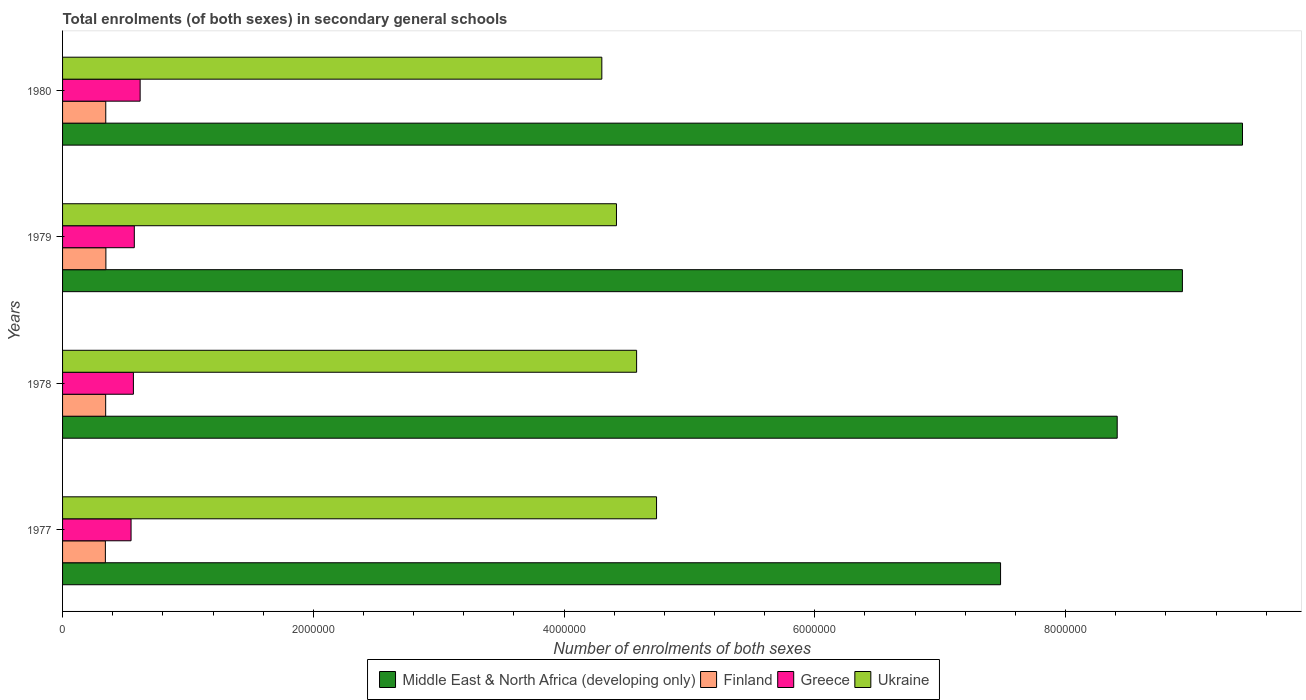How many different coloured bars are there?
Provide a succinct answer. 4. Are the number of bars per tick equal to the number of legend labels?
Offer a very short reply. Yes. Are the number of bars on each tick of the Y-axis equal?
Your answer should be very brief. Yes. How many bars are there on the 1st tick from the top?
Offer a terse response. 4. What is the label of the 2nd group of bars from the top?
Your answer should be compact. 1979. In how many cases, is the number of bars for a given year not equal to the number of legend labels?
Provide a succinct answer. 0. What is the number of enrolments in secondary schools in Ukraine in 1979?
Provide a succinct answer. 4.42e+06. Across all years, what is the maximum number of enrolments in secondary schools in Greece?
Keep it short and to the point. 6.19e+05. Across all years, what is the minimum number of enrolments in secondary schools in Ukraine?
Ensure brevity in your answer.  4.30e+06. What is the total number of enrolments in secondary schools in Ukraine in the graph?
Provide a short and direct response. 1.80e+07. What is the difference between the number of enrolments in secondary schools in Middle East & North Africa (developing only) in 1978 and that in 1979?
Give a very brief answer. -5.20e+05. What is the difference between the number of enrolments in secondary schools in Middle East & North Africa (developing only) in 1980 and the number of enrolments in secondary schools in Finland in 1977?
Provide a short and direct response. 9.07e+06. What is the average number of enrolments in secondary schools in Finland per year?
Provide a short and direct response. 3.44e+05. In the year 1978, what is the difference between the number of enrolments in secondary schools in Finland and number of enrolments in secondary schools in Middle East & North Africa (developing only)?
Ensure brevity in your answer.  -8.07e+06. In how many years, is the number of enrolments in secondary schools in Finland greater than 8400000 ?
Keep it short and to the point. 0. What is the ratio of the number of enrolments in secondary schools in Ukraine in 1979 to that in 1980?
Your answer should be very brief. 1.03. Is the number of enrolments in secondary schools in Middle East & North Africa (developing only) in 1978 less than that in 1980?
Give a very brief answer. Yes. Is the difference between the number of enrolments in secondary schools in Finland in 1979 and 1980 greater than the difference between the number of enrolments in secondary schools in Middle East & North Africa (developing only) in 1979 and 1980?
Make the answer very short. Yes. What is the difference between the highest and the second highest number of enrolments in secondary schools in Middle East & North Africa (developing only)?
Provide a succinct answer. 4.79e+05. What is the difference between the highest and the lowest number of enrolments in secondary schools in Middle East & North Africa (developing only)?
Your response must be concise. 1.93e+06. Is it the case that in every year, the sum of the number of enrolments in secondary schools in Ukraine and number of enrolments in secondary schools in Middle East & North Africa (developing only) is greater than the sum of number of enrolments in secondary schools in Finland and number of enrolments in secondary schools in Greece?
Your answer should be very brief. No. What does the 2nd bar from the top in 1977 represents?
Make the answer very short. Greece. What does the 3rd bar from the bottom in 1977 represents?
Offer a terse response. Greece. Are all the bars in the graph horizontal?
Keep it short and to the point. Yes. What is the difference between two consecutive major ticks on the X-axis?
Your response must be concise. 2.00e+06. Are the values on the major ticks of X-axis written in scientific E-notation?
Provide a short and direct response. No. Does the graph contain grids?
Ensure brevity in your answer.  No. What is the title of the graph?
Keep it short and to the point. Total enrolments (of both sexes) in secondary general schools. Does "Tonga" appear as one of the legend labels in the graph?
Make the answer very short. No. What is the label or title of the X-axis?
Give a very brief answer. Number of enrolments of both sexes. What is the label or title of the Y-axis?
Offer a terse response. Years. What is the Number of enrolments of both sexes in Middle East & North Africa (developing only) in 1977?
Offer a terse response. 7.48e+06. What is the Number of enrolments of both sexes of Finland in 1977?
Your answer should be very brief. 3.41e+05. What is the Number of enrolments of both sexes in Greece in 1977?
Keep it short and to the point. 5.46e+05. What is the Number of enrolments of both sexes in Ukraine in 1977?
Offer a very short reply. 4.74e+06. What is the Number of enrolments of both sexes of Middle East & North Africa (developing only) in 1978?
Your response must be concise. 8.41e+06. What is the Number of enrolments of both sexes in Finland in 1978?
Provide a short and direct response. 3.44e+05. What is the Number of enrolments of both sexes in Greece in 1978?
Your answer should be very brief. 5.65e+05. What is the Number of enrolments of both sexes of Ukraine in 1978?
Your response must be concise. 4.58e+06. What is the Number of enrolments of both sexes of Middle East & North Africa (developing only) in 1979?
Give a very brief answer. 8.93e+06. What is the Number of enrolments of both sexes of Finland in 1979?
Provide a short and direct response. 3.46e+05. What is the Number of enrolments of both sexes in Greece in 1979?
Ensure brevity in your answer.  5.72e+05. What is the Number of enrolments of both sexes in Ukraine in 1979?
Ensure brevity in your answer.  4.42e+06. What is the Number of enrolments of both sexes in Middle East & North Africa (developing only) in 1980?
Offer a very short reply. 9.41e+06. What is the Number of enrolments of both sexes of Finland in 1980?
Offer a very short reply. 3.45e+05. What is the Number of enrolments of both sexes in Greece in 1980?
Make the answer very short. 6.19e+05. What is the Number of enrolments of both sexes of Ukraine in 1980?
Your response must be concise. 4.30e+06. Across all years, what is the maximum Number of enrolments of both sexes in Middle East & North Africa (developing only)?
Your answer should be very brief. 9.41e+06. Across all years, what is the maximum Number of enrolments of both sexes in Finland?
Provide a succinct answer. 3.46e+05. Across all years, what is the maximum Number of enrolments of both sexes in Greece?
Keep it short and to the point. 6.19e+05. Across all years, what is the maximum Number of enrolments of both sexes of Ukraine?
Your answer should be compact. 4.74e+06. Across all years, what is the minimum Number of enrolments of both sexes of Middle East & North Africa (developing only)?
Keep it short and to the point. 7.48e+06. Across all years, what is the minimum Number of enrolments of both sexes in Finland?
Your answer should be compact. 3.41e+05. Across all years, what is the minimum Number of enrolments of both sexes in Greece?
Offer a terse response. 5.46e+05. Across all years, what is the minimum Number of enrolments of both sexes of Ukraine?
Offer a very short reply. 4.30e+06. What is the total Number of enrolments of both sexes in Middle East & North Africa (developing only) in the graph?
Ensure brevity in your answer.  3.42e+07. What is the total Number of enrolments of both sexes in Finland in the graph?
Give a very brief answer. 1.38e+06. What is the total Number of enrolments of both sexes in Greece in the graph?
Give a very brief answer. 2.30e+06. What is the total Number of enrolments of both sexes of Ukraine in the graph?
Provide a short and direct response. 1.80e+07. What is the difference between the Number of enrolments of both sexes of Middle East & North Africa (developing only) in 1977 and that in 1978?
Offer a terse response. -9.30e+05. What is the difference between the Number of enrolments of both sexes in Finland in 1977 and that in 1978?
Keep it short and to the point. -2338. What is the difference between the Number of enrolments of both sexes in Greece in 1977 and that in 1978?
Provide a succinct answer. -1.87e+04. What is the difference between the Number of enrolments of both sexes of Ukraine in 1977 and that in 1978?
Provide a short and direct response. 1.59e+05. What is the difference between the Number of enrolments of both sexes of Middle East & North Africa (developing only) in 1977 and that in 1979?
Your answer should be compact. -1.45e+06. What is the difference between the Number of enrolments of both sexes of Finland in 1977 and that in 1979?
Keep it short and to the point. -4182. What is the difference between the Number of enrolments of both sexes of Greece in 1977 and that in 1979?
Provide a short and direct response. -2.59e+04. What is the difference between the Number of enrolments of both sexes of Ukraine in 1977 and that in 1979?
Provide a succinct answer. 3.20e+05. What is the difference between the Number of enrolments of both sexes in Middle East & North Africa (developing only) in 1977 and that in 1980?
Offer a terse response. -1.93e+06. What is the difference between the Number of enrolments of both sexes in Finland in 1977 and that in 1980?
Keep it short and to the point. -3103. What is the difference between the Number of enrolments of both sexes of Greece in 1977 and that in 1980?
Provide a short and direct response. -7.23e+04. What is the difference between the Number of enrolments of both sexes in Ukraine in 1977 and that in 1980?
Offer a very short reply. 4.36e+05. What is the difference between the Number of enrolments of both sexes in Middle East & North Africa (developing only) in 1978 and that in 1979?
Offer a very short reply. -5.20e+05. What is the difference between the Number of enrolments of both sexes in Finland in 1978 and that in 1979?
Keep it short and to the point. -1844. What is the difference between the Number of enrolments of both sexes in Greece in 1978 and that in 1979?
Give a very brief answer. -7241. What is the difference between the Number of enrolments of both sexes in Ukraine in 1978 and that in 1979?
Provide a succinct answer. 1.61e+05. What is the difference between the Number of enrolments of both sexes in Middle East & North Africa (developing only) in 1978 and that in 1980?
Offer a terse response. -9.99e+05. What is the difference between the Number of enrolments of both sexes of Finland in 1978 and that in 1980?
Make the answer very short. -765. What is the difference between the Number of enrolments of both sexes of Greece in 1978 and that in 1980?
Give a very brief answer. -5.36e+04. What is the difference between the Number of enrolments of both sexes in Ukraine in 1978 and that in 1980?
Offer a very short reply. 2.77e+05. What is the difference between the Number of enrolments of both sexes of Middle East & North Africa (developing only) in 1979 and that in 1980?
Your answer should be very brief. -4.79e+05. What is the difference between the Number of enrolments of both sexes of Finland in 1979 and that in 1980?
Your response must be concise. 1079. What is the difference between the Number of enrolments of both sexes of Greece in 1979 and that in 1980?
Keep it short and to the point. -4.64e+04. What is the difference between the Number of enrolments of both sexes in Ukraine in 1979 and that in 1980?
Make the answer very short. 1.17e+05. What is the difference between the Number of enrolments of both sexes in Middle East & North Africa (developing only) in 1977 and the Number of enrolments of both sexes in Finland in 1978?
Offer a very short reply. 7.14e+06. What is the difference between the Number of enrolments of both sexes in Middle East & North Africa (developing only) in 1977 and the Number of enrolments of both sexes in Greece in 1978?
Offer a very short reply. 6.92e+06. What is the difference between the Number of enrolments of both sexes of Middle East & North Africa (developing only) in 1977 and the Number of enrolments of both sexes of Ukraine in 1978?
Keep it short and to the point. 2.90e+06. What is the difference between the Number of enrolments of both sexes of Finland in 1977 and the Number of enrolments of both sexes of Greece in 1978?
Offer a terse response. -2.24e+05. What is the difference between the Number of enrolments of both sexes of Finland in 1977 and the Number of enrolments of both sexes of Ukraine in 1978?
Make the answer very short. -4.24e+06. What is the difference between the Number of enrolments of both sexes in Greece in 1977 and the Number of enrolments of both sexes in Ukraine in 1978?
Your response must be concise. -4.03e+06. What is the difference between the Number of enrolments of both sexes in Middle East & North Africa (developing only) in 1977 and the Number of enrolments of both sexes in Finland in 1979?
Keep it short and to the point. 7.14e+06. What is the difference between the Number of enrolments of both sexes in Middle East & North Africa (developing only) in 1977 and the Number of enrolments of both sexes in Greece in 1979?
Offer a terse response. 6.91e+06. What is the difference between the Number of enrolments of both sexes in Middle East & North Africa (developing only) in 1977 and the Number of enrolments of both sexes in Ukraine in 1979?
Your answer should be very brief. 3.06e+06. What is the difference between the Number of enrolments of both sexes of Finland in 1977 and the Number of enrolments of both sexes of Greece in 1979?
Your response must be concise. -2.31e+05. What is the difference between the Number of enrolments of both sexes in Finland in 1977 and the Number of enrolments of both sexes in Ukraine in 1979?
Make the answer very short. -4.08e+06. What is the difference between the Number of enrolments of both sexes of Greece in 1977 and the Number of enrolments of both sexes of Ukraine in 1979?
Provide a succinct answer. -3.87e+06. What is the difference between the Number of enrolments of both sexes in Middle East & North Africa (developing only) in 1977 and the Number of enrolments of both sexes in Finland in 1980?
Provide a short and direct response. 7.14e+06. What is the difference between the Number of enrolments of both sexes in Middle East & North Africa (developing only) in 1977 and the Number of enrolments of both sexes in Greece in 1980?
Your answer should be compact. 6.86e+06. What is the difference between the Number of enrolments of both sexes in Middle East & North Africa (developing only) in 1977 and the Number of enrolments of both sexes in Ukraine in 1980?
Make the answer very short. 3.18e+06. What is the difference between the Number of enrolments of both sexes in Finland in 1977 and the Number of enrolments of both sexes in Greece in 1980?
Your answer should be very brief. -2.77e+05. What is the difference between the Number of enrolments of both sexes in Finland in 1977 and the Number of enrolments of both sexes in Ukraine in 1980?
Your response must be concise. -3.96e+06. What is the difference between the Number of enrolments of both sexes of Greece in 1977 and the Number of enrolments of both sexes of Ukraine in 1980?
Your answer should be compact. -3.75e+06. What is the difference between the Number of enrolments of both sexes in Middle East & North Africa (developing only) in 1978 and the Number of enrolments of both sexes in Finland in 1979?
Make the answer very short. 8.07e+06. What is the difference between the Number of enrolments of both sexes of Middle East & North Africa (developing only) in 1978 and the Number of enrolments of both sexes of Greece in 1979?
Give a very brief answer. 7.84e+06. What is the difference between the Number of enrolments of both sexes of Middle East & North Africa (developing only) in 1978 and the Number of enrolments of both sexes of Ukraine in 1979?
Your answer should be very brief. 3.99e+06. What is the difference between the Number of enrolments of both sexes of Finland in 1978 and the Number of enrolments of both sexes of Greece in 1979?
Provide a short and direct response. -2.29e+05. What is the difference between the Number of enrolments of both sexes in Finland in 1978 and the Number of enrolments of both sexes in Ukraine in 1979?
Keep it short and to the point. -4.07e+06. What is the difference between the Number of enrolments of both sexes in Greece in 1978 and the Number of enrolments of both sexes in Ukraine in 1979?
Offer a terse response. -3.85e+06. What is the difference between the Number of enrolments of both sexes in Middle East & North Africa (developing only) in 1978 and the Number of enrolments of both sexes in Finland in 1980?
Offer a very short reply. 8.07e+06. What is the difference between the Number of enrolments of both sexes of Middle East & North Africa (developing only) in 1978 and the Number of enrolments of both sexes of Greece in 1980?
Provide a short and direct response. 7.79e+06. What is the difference between the Number of enrolments of both sexes in Middle East & North Africa (developing only) in 1978 and the Number of enrolments of both sexes in Ukraine in 1980?
Your answer should be very brief. 4.11e+06. What is the difference between the Number of enrolments of both sexes in Finland in 1978 and the Number of enrolments of both sexes in Greece in 1980?
Your answer should be compact. -2.75e+05. What is the difference between the Number of enrolments of both sexes of Finland in 1978 and the Number of enrolments of both sexes of Ukraine in 1980?
Your answer should be compact. -3.96e+06. What is the difference between the Number of enrolments of both sexes in Greece in 1978 and the Number of enrolments of both sexes in Ukraine in 1980?
Your response must be concise. -3.74e+06. What is the difference between the Number of enrolments of both sexes of Middle East & North Africa (developing only) in 1979 and the Number of enrolments of both sexes of Finland in 1980?
Keep it short and to the point. 8.59e+06. What is the difference between the Number of enrolments of both sexes of Middle East & North Africa (developing only) in 1979 and the Number of enrolments of both sexes of Greece in 1980?
Offer a very short reply. 8.31e+06. What is the difference between the Number of enrolments of both sexes of Middle East & North Africa (developing only) in 1979 and the Number of enrolments of both sexes of Ukraine in 1980?
Your response must be concise. 4.63e+06. What is the difference between the Number of enrolments of both sexes of Finland in 1979 and the Number of enrolments of both sexes of Greece in 1980?
Your answer should be compact. -2.73e+05. What is the difference between the Number of enrolments of both sexes of Finland in 1979 and the Number of enrolments of both sexes of Ukraine in 1980?
Your answer should be very brief. -3.96e+06. What is the difference between the Number of enrolments of both sexes of Greece in 1979 and the Number of enrolments of both sexes of Ukraine in 1980?
Make the answer very short. -3.73e+06. What is the average Number of enrolments of both sexes in Middle East & North Africa (developing only) per year?
Ensure brevity in your answer.  8.56e+06. What is the average Number of enrolments of both sexes in Finland per year?
Keep it short and to the point. 3.44e+05. What is the average Number of enrolments of both sexes in Greece per year?
Make the answer very short. 5.76e+05. What is the average Number of enrolments of both sexes in Ukraine per year?
Your response must be concise. 4.51e+06. In the year 1977, what is the difference between the Number of enrolments of both sexes of Middle East & North Africa (developing only) and Number of enrolments of both sexes of Finland?
Offer a terse response. 7.14e+06. In the year 1977, what is the difference between the Number of enrolments of both sexes in Middle East & North Africa (developing only) and Number of enrolments of both sexes in Greece?
Your answer should be very brief. 6.94e+06. In the year 1977, what is the difference between the Number of enrolments of both sexes of Middle East & North Africa (developing only) and Number of enrolments of both sexes of Ukraine?
Keep it short and to the point. 2.74e+06. In the year 1977, what is the difference between the Number of enrolments of both sexes in Finland and Number of enrolments of both sexes in Greece?
Provide a short and direct response. -2.05e+05. In the year 1977, what is the difference between the Number of enrolments of both sexes in Finland and Number of enrolments of both sexes in Ukraine?
Ensure brevity in your answer.  -4.40e+06. In the year 1977, what is the difference between the Number of enrolments of both sexes in Greece and Number of enrolments of both sexes in Ukraine?
Provide a short and direct response. -4.19e+06. In the year 1978, what is the difference between the Number of enrolments of both sexes of Middle East & North Africa (developing only) and Number of enrolments of both sexes of Finland?
Provide a succinct answer. 8.07e+06. In the year 1978, what is the difference between the Number of enrolments of both sexes in Middle East & North Africa (developing only) and Number of enrolments of both sexes in Greece?
Give a very brief answer. 7.85e+06. In the year 1978, what is the difference between the Number of enrolments of both sexes in Middle East & North Africa (developing only) and Number of enrolments of both sexes in Ukraine?
Your answer should be compact. 3.83e+06. In the year 1978, what is the difference between the Number of enrolments of both sexes of Finland and Number of enrolments of both sexes of Greece?
Provide a short and direct response. -2.21e+05. In the year 1978, what is the difference between the Number of enrolments of both sexes in Finland and Number of enrolments of both sexes in Ukraine?
Your response must be concise. -4.23e+06. In the year 1978, what is the difference between the Number of enrolments of both sexes in Greece and Number of enrolments of both sexes in Ukraine?
Keep it short and to the point. -4.01e+06. In the year 1979, what is the difference between the Number of enrolments of both sexes of Middle East & North Africa (developing only) and Number of enrolments of both sexes of Finland?
Offer a terse response. 8.59e+06. In the year 1979, what is the difference between the Number of enrolments of both sexes of Middle East & North Africa (developing only) and Number of enrolments of both sexes of Greece?
Offer a terse response. 8.36e+06. In the year 1979, what is the difference between the Number of enrolments of both sexes in Middle East & North Africa (developing only) and Number of enrolments of both sexes in Ukraine?
Offer a very short reply. 4.51e+06. In the year 1979, what is the difference between the Number of enrolments of both sexes in Finland and Number of enrolments of both sexes in Greece?
Offer a very short reply. -2.27e+05. In the year 1979, what is the difference between the Number of enrolments of both sexes in Finland and Number of enrolments of both sexes in Ukraine?
Give a very brief answer. -4.07e+06. In the year 1979, what is the difference between the Number of enrolments of both sexes of Greece and Number of enrolments of both sexes of Ukraine?
Offer a very short reply. -3.85e+06. In the year 1980, what is the difference between the Number of enrolments of both sexes in Middle East & North Africa (developing only) and Number of enrolments of both sexes in Finland?
Offer a terse response. 9.07e+06. In the year 1980, what is the difference between the Number of enrolments of both sexes in Middle East & North Africa (developing only) and Number of enrolments of both sexes in Greece?
Offer a very short reply. 8.79e+06. In the year 1980, what is the difference between the Number of enrolments of both sexes of Middle East & North Africa (developing only) and Number of enrolments of both sexes of Ukraine?
Your response must be concise. 5.11e+06. In the year 1980, what is the difference between the Number of enrolments of both sexes in Finland and Number of enrolments of both sexes in Greece?
Your answer should be very brief. -2.74e+05. In the year 1980, what is the difference between the Number of enrolments of both sexes in Finland and Number of enrolments of both sexes in Ukraine?
Your answer should be very brief. -3.96e+06. In the year 1980, what is the difference between the Number of enrolments of both sexes of Greece and Number of enrolments of both sexes of Ukraine?
Make the answer very short. -3.68e+06. What is the ratio of the Number of enrolments of both sexes in Middle East & North Africa (developing only) in 1977 to that in 1978?
Your answer should be compact. 0.89. What is the ratio of the Number of enrolments of both sexes of Greece in 1977 to that in 1978?
Keep it short and to the point. 0.97. What is the ratio of the Number of enrolments of both sexes in Ukraine in 1977 to that in 1978?
Your answer should be very brief. 1.03. What is the ratio of the Number of enrolments of both sexes in Middle East & North Africa (developing only) in 1977 to that in 1979?
Provide a short and direct response. 0.84. What is the ratio of the Number of enrolments of both sexes in Finland in 1977 to that in 1979?
Give a very brief answer. 0.99. What is the ratio of the Number of enrolments of both sexes of Greece in 1977 to that in 1979?
Your answer should be very brief. 0.95. What is the ratio of the Number of enrolments of both sexes in Ukraine in 1977 to that in 1979?
Provide a short and direct response. 1.07. What is the ratio of the Number of enrolments of both sexes of Middle East & North Africa (developing only) in 1977 to that in 1980?
Provide a succinct answer. 0.8. What is the ratio of the Number of enrolments of both sexes of Greece in 1977 to that in 1980?
Offer a terse response. 0.88. What is the ratio of the Number of enrolments of both sexes of Ukraine in 1977 to that in 1980?
Offer a terse response. 1.1. What is the ratio of the Number of enrolments of both sexes in Middle East & North Africa (developing only) in 1978 to that in 1979?
Provide a short and direct response. 0.94. What is the ratio of the Number of enrolments of both sexes of Finland in 1978 to that in 1979?
Your response must be concise. 0.99. What is the ratio of the Number of enrolments of both sexes in Greece in 1978 to that in 1979?
Your answer should be compact. 0.99. What is the ratio of the Number of enrolments of both sexes in Ukraine in 1978 to that in 1979?
Provide a short and direct response. 1.04. What is the ratio of the Number of enrolments of both sexes in Middle East & North Africa (developing only) in 1978 to that in 1980?
Provide a succinct answer. 0.89. What is the ratio of the Number of enrolments of both sexes of Greece in 1978 to that in 1980?
Offer a very short reply. 0.91. What is the ratio of the Number of enrolments of both sexes in Ukraine in 1978 to that in 1980?
Provide a succinct answer. 1.06. What is the ratio of the Number of enrolments of both sexes in Middle East & North Africa (developing only) in 1979 to that in 1980?
Your answer should be very brief. 0.95. What is the ratio of the Number of enrolments of both sexes in Greece in 1979 to that in 1980?
Give a very brief answer. 0.93. What is the ratio of the Number of enrolments of both sexes in Ukraine in 1979 to that in 1980?
Make the answer very short. 1.03. What is the difference between the highest and the second highest Number of enrolments of both sexes of Middle East & North Africa (developing only)?
Keep it short and to the point. 4.79e+05. What is the difference between the highest and the second highest Number of enrolments of both sexes in Finland?
Ensure brevity in your answer.  1079. What is the difference between the highest and the second highest Number of enrolments of both sexes in Greece?
Make the answer very short. 4.64e+04. What is the difference between the highest and the second highest Number of enrolments of both sexes of Ukraine?
Offer a terse response. 1.59e+05. What is the difference between the highest and the lowest Number of enrolments of both sexes of Middle East & North Africa (developing only)?
Provide a short and direct response. 1.93e+06. What is the difference between the highest and the lowest Number of enrolments of both sexes in Finland?
Give a very brief answer. 4182. What is the difference between the highest and the lowest Number of enrolments of both sexes of Greece?
Provide a short and direct response. 7.23e+04. What is the difference between the highest and the lowest Number of enrolments of both sexes of Ukraine?
Keep it short and to the point. 4.36e+05. 